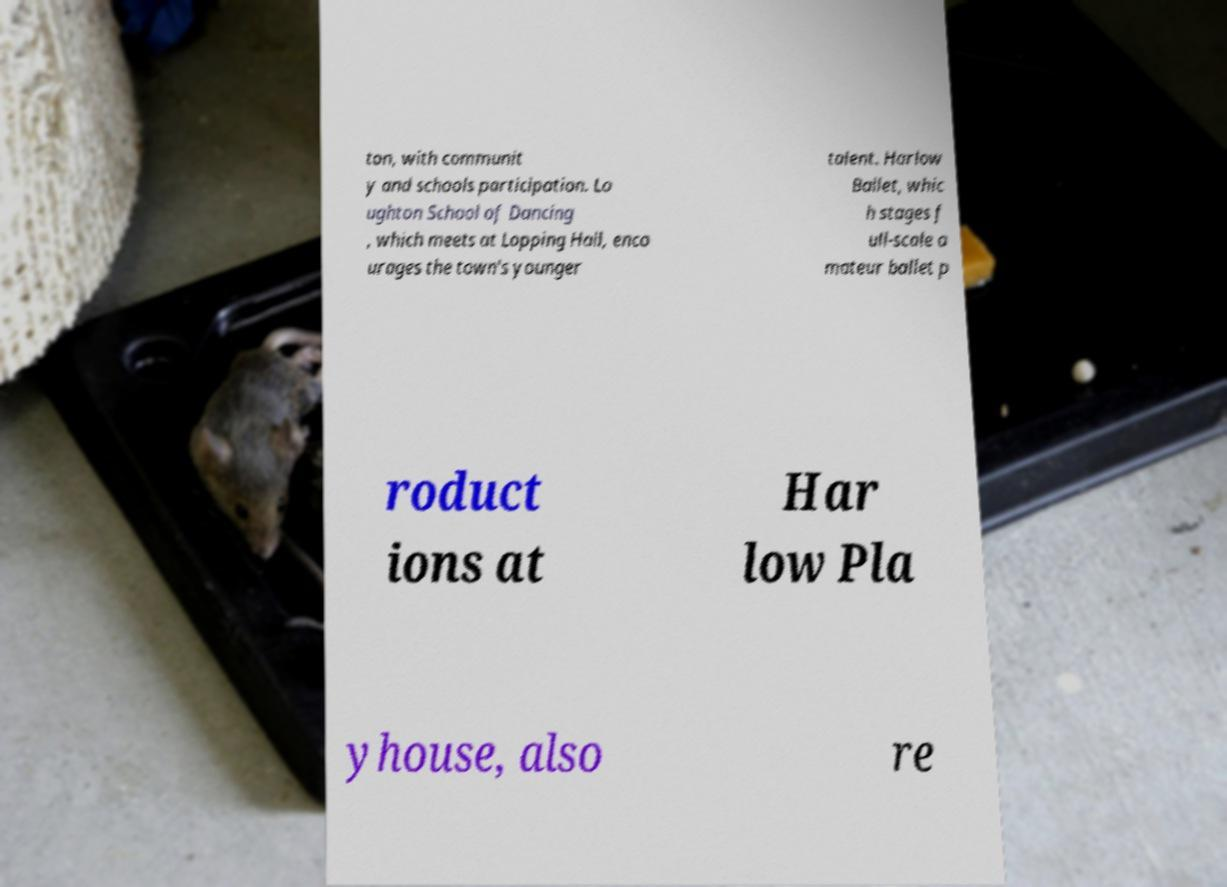Could you extract and type out the text from this image? ton, with communit y and schools participation. Lo ughton School of Dancing , which meets at Lopping Hall, enco urages the town's younger talent. Harlow Ballet, whic h stages f ull-scale a mateur ballet p roduct ions at Har low Pla yhouse, also re 